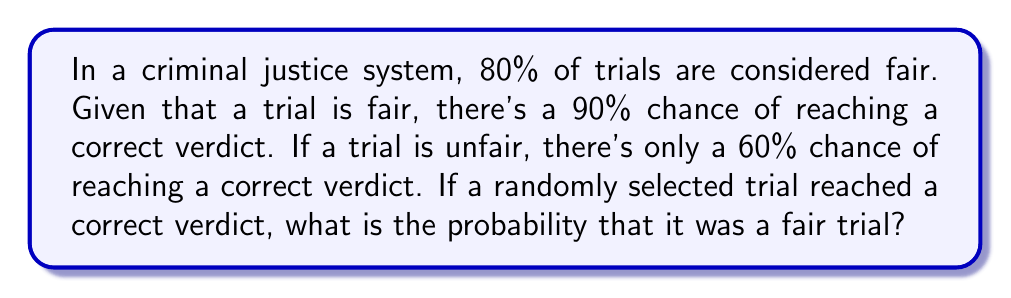Teach me how to tackle this problem. Let's approach this problem using Bayes' theorem and conditional probability. We'll define the following events:

$F$: The trial is fair
$C$: The verdict is correct

We're given the following probabilities:

$P(F) = 0.80$ (80% of trials are fair)
$P(C|F) = 0.90$ (90% chance of correct verdict given a fair trial)
$P(C|\text{not }F) = 0.60$ (60% chance of correct verdict given an unfair trial)

We want to find $P(F|C)$, the probability that a trial was fair given that it reached a correct verdict.

Bayes' theorem states:

$$P(F|C) = \frac{P(C|F) \cdot P(F)}{P(C)}$$

We need to calculate $P(C)$ using the law of total probability:

$$P(C) = P(C|F) \cdot P(F) + P(C|\text{not }F) \cdot P(\text{not }F)$$

$P(\text{not }F) = 1 - P(F) = 1 - 0.80 = 0.20$

Now, let's calculate $P(C)$:

$$\begin{align*}
P(C) &= 0.90 \cdot 0.80 + 0.60 \cdot 0.20 \\
&= 0.72 + 0.12 \\
&= 0.84
\end{align*}$$

Now we can apply Bayes' theorem:

$$\begin{align*}
P(F|C) &= \frac{P(C|F) \cdot P(F)}{P(C)} \\
&= \frac{0.90 \cdot 0.80}{0.84} \\
&= \frac{0.72}{0.84} \\
&\approx 0.8571
\end{align*}$$

Therefore, the probability that a trial was fair, given that it reached a correct verdict, is approximately 0.8571 or 85.71%.
Answer: $P(F|C) \approx 0.8571$ or 85.71% 